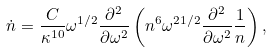<formula> <loc_0><loc_0><loc_500><loc_500>\dot { n } = \frac { C } { \kappa ^ { 1 0 } } \omega ^ { 1 / 2 } \frac { \partial ^ { 2 } } { \partial \omega ^ { 2 } } \left ( n ^ { 6 } \omega ^ { 2 1 / 2 } \frac { \partial ^ { 2 } } { \partial \omega ^ { 2 } } \frac { 1 } { n } \right ) ,</formula> 